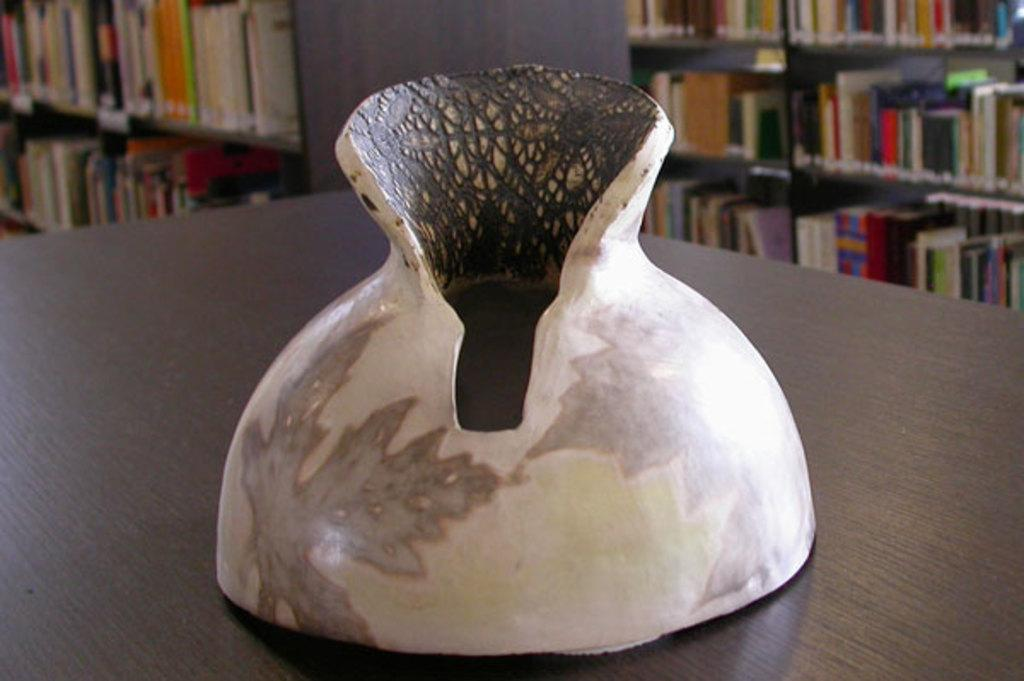What is the main object on the platform in the image? The fact does not specify the type of object on the platform, so we cannot definitively answer this question. What can be seen in the background of the image? There are bookshelves in the background of the image. What sign is displayed on the object in the image? There is no mention of a sign in the image, so we cannot answer this question. 